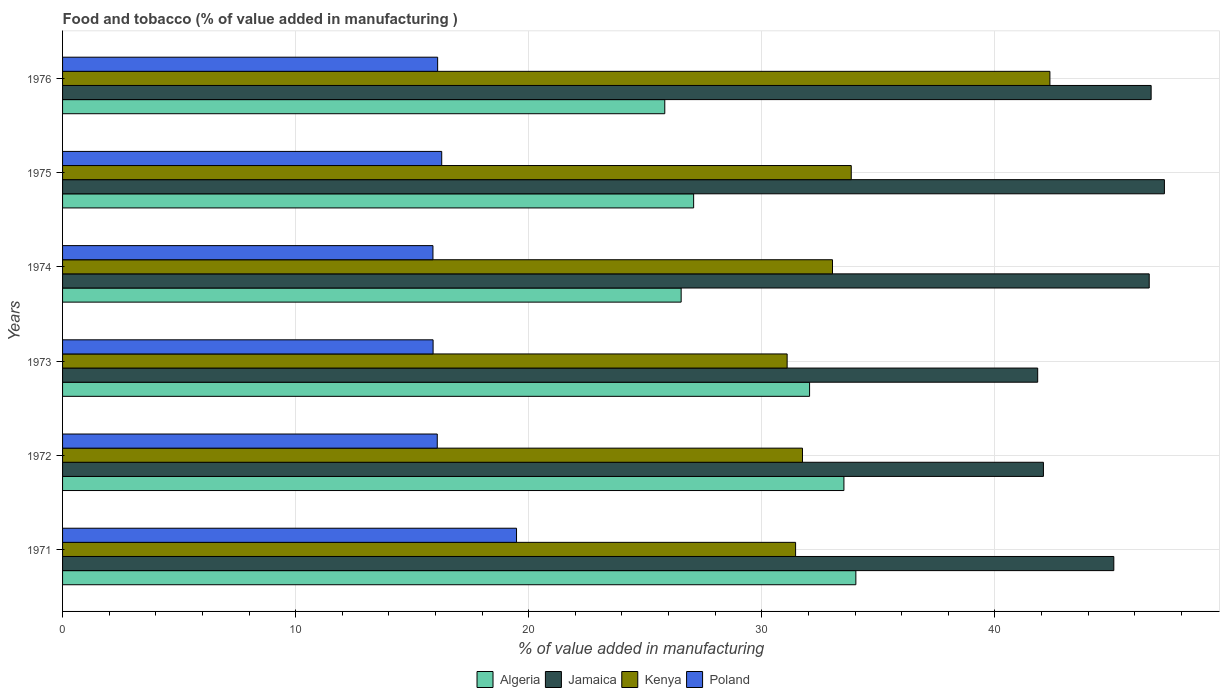How many different coloured bars are there?
Provide a short and direct response. 4. What is the label of the 1st group of bars from the top?
Make the answer very short. 1976. In how many cases, is the number of bars for a given year not equal to the number of legend labels?
Provide a succinct answer. 0. What is the value added in manufacturing food and tobacco in Algeria in 1976?
Your answer should be very brief. 25.84. Across all years, what is the maximum value added in manufacturing food and tobacco in Poland?
Provide a succinct answer. 19.48. Across all years, what is the minimum value added in manufacturing food and tobacco in Jamaica?
Your response must be concise. 41.84. In which year was the value added in manufacturing food and tobacco in Kenya maximum?
Your answer should be compact. 1976. In which year was the value added in manufacturing food and tobacco in Poland minimum?
Provide a succinct answer. 1974. What is the total value added in manufacturing food and tobacco in Algeria in the graph?
Ensure brevity in your answer.  179.06. What is the difference between the value added in manufacturing food and tobacco in Algeria in 1973 and that in 1974?
Offer a very short reply. 5.51. What is the difference between the value added in manufacturing food and tobacco in Jamaica in 1973 and the value added in manufacturing food and tobacco in Algeria in 1974?
Your response must be concise. 15.3. What is the average value added in manufacturing food and tobacco in Kenya per year?
Offer a very short reply. 33.92. In the year 1971, what is the difference between the value added in manufacturing food and tobacco in Poland and value added in manufacturing food and tobacco in Kenya?
Provide a short and direct response. -11.97. What is the ratio of the value added in manufacturing food and tobacco in Jamaica in 1971 to that in 1974?
Ensure brevity in your answer.  0.97. Is the difference between the value added in manufacturing food and tobacco in Poland in 1974 and 1975 greater than the difference between the value added in manufacturing food and tobacco in Kenya in 1974 and 1975?
Your response must be concise. Yes. What is the difference between the highest and the second highest value added in manufacturing food and tobacco in Algeria?
Make the answer very short. 0.51. What is the difference between the highest and the lowest value added in manufacturing food and tobacco in Poland?
Provide a short and direct response. 3.59. Is the sum of the value added in manufacturing food and tobacco in Algeria in 1975 and 1976 greater than the maximum value added in manufacturing food and tobacco in Jamaica across all years?
Offer a terse response. Yes. Is it the case that in every year, the sum of the value added in manufacturing food and tobacco in Poland and value added in manufacturing food and tobacco in Jamaica is greater than the sum of value added in manufacturing food and tobacco in Algeria and value added in manufacturing food and tobacco in Kenya?
Offer a terse response. No. What does the 4th bar from the top in 1976 represents?
Your answer should be compact. Algeria. What does the 3rd bar from the bottom in 1972 represents?
Ensure brevity in your answer.  Kenya. How many years are there in the graph?
Your response must be concise. 6. What is the difference between two consecutive major ticks on the X-axis?
Offer a very short reply. 10. How many legend labels are there?
Keep it short and to the point. 4. How are the legend labels stacked?
Provide a succinct answer. Horizontal. What is the title of the graph?
Offer a very short reply. Food and tobacco (% of value added in manufacturing ). What is the label or title of the X-axis?
Provide a succinct answer. % of value added in manufacturing. What is the label or title of the Y-axis?
Give a very brief answer. Years. What is the % of value added in manufacturing of Algeria in 1971?
Provide a short and direct response. 34.04. What is the % of value added in manufacturing in Jamaica in 1971?
Give a very brief answer. 45.1. What is the % of value added in manufacturing of Kenya in 1971?
Keep it short and to the point. 31.45. What is the % of value added in manufacturing in Poland in 1971?
Give a very brief answer. 19.48. What is the % of value added in manufacturing of Algeria in 1972?
Offer a very short reply. 33.52. What is the % of value added in manufacturing in Jamaica in 1972?
Your answer should be compact. 42.08. What is the % of value added in manufacturing of Kenya in 1972?
Provide a succinct answer. 31.75. What is the % of value added in manufacturing in Poland in 1972?
Provide a short and direct response. 16.08. What is the % of value added in manufacturing in Algeria in 1973?
Provide a succinct answer. 32.05. What is the % of value added in manufacturing in Jamaica in 1973?
Provide a succinct answer. 41.84. What is the % of value added in manufacturing of Kenya in 1973?
Make the answer very short. 31.09. What is the % of value added in manufacturing in Poland in 1973?
Ensure brevity in your answer.  15.9. What is the % of value added in manufacturing in Algeria in 1974?
Your answer should be very brief. 26.54. What is the % of value added in manufacturing of Jamaica in 1974?
Ensure brevity in your answer.  46.62. What is the % of value added in manufacturing in Kenya in 1974?
Provide a short and direct response. 33.03. What is the % of value added in manufacturing in Poland in 1974?
Provide a succinct answer. 15.89. What is the % of value added in manufacturing of Algeria in 1975?
Your response must be concise. 27.08. What is the % of value added in manufacturing of Jamaica in 1975?
Offer a terse response. 47.27. What is the % of value added in manufacturing of Kenya in 1975?
Ensure brevity in your answer.  33.84. What is the % of value added in manufacturing in Poland in 1975?
Keep it short and to the point. 16.27. What is the % of value added in manufacturing of Algeria in 1976?
Make the answer very short. 25.84. What is the % of value added in manufacturing of Jamaica in 1976?
Make the answer very short. 46.7. What is the % of value added in manufacturing of Kenya in 1976?
Your answer should be very brief. 42.36. What is the % of value added in manufacturing of Poland in 1976?
Your response must be concise. 16.09. Across all years, what is the maximum % of value added in manufacturing in Algeria?
Give a very brief answer. 34.04. Across all years, what is the maximum % of value added in manufacturing of Jamaica?
Give a very brief answer. 47.27. Across all years, what is the maximum % of value added in manufacturing of Kenya?
Keep it short and to the point. 42.36. Across all years, what is the maximum % of value added in manufacturing in Poland?
Provide a succinct answer. 19.48. Across all years, what is the minimum % of value added in manufacturing in Algeria?
Offer a terse response. 25.84. Across all years, what is the minimum % of value added in manufacturing in Jamaica?
Provide a short and direct response. 41.84. Across all years, what is the minimum % of value added in manufacturing in Kenya?
Provide a short and direct response. 31.09. Across all years, what is the minimum % of value added in manufacturing in Poland?
Provide a short and direct response. 15.89. What is the total % of value added in manufacturing in Algeria in the graph?
Ensure brevity in your answer.  179.06. What is the total % of value added in manufacturing of Jamaica in the graph?
Your answer should be compact. 269.62. What is the total % of value added in manufacturing of Kenya in the graph?
Offer a very short reply. 203.51. What is the total % of value added in manufacturing in Poland in the graph?
Ensure brevity in your answer.  99.7. What is the difference between the % of value added in manufacturing of Algeria in 1971 and that in 1972?
Your answer should be compact. 0.51. What is the difference between the % of value added in manufacturing in Jamaica in 1971 and that in 1972?
Offer a very short reply. 3.02. What is the difference between the % of value added in manufacturing of Kenya in 1971 and that in 1972?
Keep it short and to the point. -0.3. What is the difference between the % of value added in manufacturing of Poland in 1971 and that in 1972?
Your answer should be very brief. 3.4. What is the difference between the % of value added in manufacturing in Algeria in 1971 and that in 1973?
Your answer should be compact. 1.99. What is the difference between the % of value added in manufacturing in Jamaica in 1971 and that in 1973?
Your answer should be very brief. 3.27. What is the difference between the % of value added in manufacturing of Kenya in 1971 and that in 1973?
Make the answer very short. 0.36. What is the difference between the % of value added in manufacturing of Poland in 1971 and that in 1973?
Your answer should be compact. 3.58. What is the difference between the % of value added in manufacturing of Algeria in 1971 and that in 1974?
Make the answer very short. 7.5. What is the difference between the % of value added in manufacturing in Jamaica in 1971 and that in 1974?
Offer a very short reply. -1.52. What is the difference between the % of value added in manufacturing in Kenya in 1971 and that in 1974?
Your answer should be very brief. -1.58. What is the difference between the % of value added in manufacturing in Poland in 1971 and that in 1974?
Provide a short and direct response. 3.59. What is the difference between the % of value added in manufacturing in Algeria in 1971 and that in 1975?
Ensure brevity in your answer.  6.96. What is the difference between the % of value added in manufacturing in Jamaica in 1971 and that in 1975?
Give a very brief answer. -2.17. What is the difference between the % of value added in manufacturing of Kenya in 1971 and that in 1975?
Provide a short and direct response. -2.39. What is the difference between the % of value added in manufacturing in Poland in 1971 and that in 1975?
Keep it short and to the point. 3.21. What is the difference between the % of value added in manufacturing in Algeria in 1971 and that in 1976?
Your response must be concise. 8.2. What is the difference between the % of value added in manufacturing in Jamaica in 1971 and that in 1976?
Your response must be concise. -1.6. What is the difference between the % of value added in manufacturing in Kenya in 1971 and that in 1976?
Offer a very short reply. -10.91. What is the difference between the % of value added in manufacturing of Poland in 1971 and that in 1976?
Make the answer very short. 3.38. What is the difference between the % of value added in manufacturing of Algeria in 1972 and that in 1973?
Your answer should be compact. 1.47. What is the difference between the % of value added in manufacturing of Jamaica in 1972 and that in 1973?
Provide a succinct answer. 0.25. What is the difference between the % of value added in manufacturing in Kenya in 1972 and that in 1973?
Your answer should be compact. 0.66. What is the difference between the % of value added in manufacturing in Poland in 1972 and that in 1973?
Your answer should be very brief. 0.18. What is the difference between the % of value added in manufacturing of Algeria in 1972 and that in 1974?
Your answer should be compact. 6.98. What is the difference between the % of value added in manufacturing of Jamaica in 1972 and that in 1974?
Ensure brevity in your answer.  -4.54. What is the difference between the % of value added in manufacturing in Kenya in 1972 and that in 1974?
Your answer should be very brief. -1.29. What is the difference between the % of value added in manufacturing in Poland in 1972 and that in 1974?
Give a very brief answer. 0.19. What is the difference between the % of value added in manufacturing of Algeria in 1972 and that in 1975?
Offer a terse response. 6.45. What is the difference between the % of value added in manufacturing in Jamaica in 1972 and that in 1975?
Your answer should be compact. -5.19. What is the difference between the % of value added in manufacturing of Kenya in 1972 and that in 1975?
Provide a succinct answer. -2.09. What is the difference between the % of value added in manufacturing in Poland in 1972 and that in 1975?
Ensure brevity in your answer.  -0.19. What is the difference between the % of value added in manufacturing of Algeria in 1972 and that in 1976?
Provide a succinct answer. 7.69. What is the difference between the % of value added in manufacturing in Jamaica in 1972 and that in 1976?
Your answer should be very brief. -4.62. What is the difference between the % of value added in manufacturing of Kenya in 1972 and that in 1976?
Provide a succinct answer. -10.61. What is the difference between the % of value added in manufacturing of Poland in 1972 and that in 1976?
Offer a very short reply. -0.02. What is the difference between the % of value added in manufacturing of Algeria in 1973 and that in 1974?
Make the answer very short. 5.51. What is the difference between the % of value added in manufacturing of Jamaica in 1973 and that in 1974?
Your answer should be very brief. -4.78. What is the difference between the % of value added in manufacturing of Kenya in 1973 and that in 1974?
Provide a short and direct response. -1.95. What is the difference between the % of value added in manufacturing of Poland in 1973 and that in 1974?
Provide a succinct answer. 0.01. What is the difference between the % of value added in manufacturing in Algeria in 1973 and that in 1975?
Offer a very short reply. 4.97. What is the difference between the % of value added in manufacturing in Jamaica in 1973 and that in 1975?
Give a very brief answer. -5.44. What is the difference between the % of value added in manufacturing in Kenya in 1973 and that in 1975?
Offer a very short reply. -2.75. What is the difference between the % of value added in manufacturing of Poland in 1973 and that in 1975?
Your answer should be compact. -0.37. What is the difference between the % of value added in manufacturing of Algeria in 1973 and that in 1976?
Your answer should be compact. 6.21. What is the difference between the % of value added in manufacturing in Jamaica in 1973 and that in 1976?
Make the answer very short. -4.87. What is the difference between the % of value added in manufacturing of Kenya in 1973 and that in 1976?
Ensure brevity in your answer.  -11.27. What is the difference between the % of value added in manufacturing in Poland in 1973 and that in 1976?
Your response must be concise. -0.2. What is the difference between the % of value added in manufacturing in Algeria in 1974 and that in 1975?
Your answer should be compact. -0.54. What is the difference between the % of value added in manufacturing of Jamaica in 1974 and that in 1975?
Offer a terse response. -0.65. What is the difference between the % of value added in manufacturing of Kenya in 1974 and that in 1975?
Make the answer very short. -0.8. What is the difference between the % of value added in manufacturing of Poland in 1974 and that in 1975?
Give a very brief answer. -0.38. What is the difference between the % of value added in manufacturing in Algeria in 1974 and that in 1976?
Provide a succinct answer. 0.7. What is the difference between the % of value added in manufacturing in Jamaica in 1974 and that in 1976?
Provide a short and direct response. -0.08. What is the difference between the % of value added in manufacturing of Kenya in 1974 and that in 1976?
Make the answer very short. -9.33. What is the difference between the % of value added in manufacturing in Poland in 1974 and that in 1976?
Your answer should be very brief. -0.2. What is the difference between the % of value added in manufacturing of Algeria in 1975 and that in 1976?
Provide a short and direct response. 1.24. What is the difference between the % of value added in manufacturing of Jamaica in 1975 and that in 1976?
Provide a short and direct response. 0.57. What is the difference between the % of value added in manufacturing of Kenya in 1975 and that in 1976?
Your answer should be very brief. -8.52. What is the difference between the % of value added in manufacturing of Poland in 1975 and that in 1976?
Provide a succinct answer. 0.17. What is the difference between the % of value added in manufacturing of Algeria in 1971 and the % of value added in manufacturing of Jamaica in 1972?
Your answer should be compact. -8.05. What is the difference between the % of value added in manufacturing of Algeria in 1971 and the % of value added in manufacturing of Kenya in 1972?
Keep it short and to the point. 2.29. What is the difference between the % of value added in manufacturing in Algeria in 1971 and the % of value added in manufacturing in Poland in 1972?
Offer a terse response. 17.96. What is the difference between the % of value added in manufacturing in Jamaica in 1971 and the % of value added in manufacturing in Kenya in 1972?
Offer a very short reply. 13.36. What is the difference between the % of value added in manufacturing in Jamaica in 1971 and the % of value added in manufacturing in Poland in 1972?
Offer a terse response. 29.03. What is the difference between the % of value added in manufacturing in Kenya in 1971 and the % of value added in manufacturing in Poland in 1972?
Your response must be concise. 15.37. What is the difference between the % of value added in manufacturing in Algeria in 1971 and the % of value added in manufacturing in Jamaica in 1973?
Ensure brevity in your answer.  -7.8. What is the difference between the % of value added in manufacturing of Algeria in 1971 and the % of value added in manufacturing of Kenya in 1973?
Offer a very short reply. 2.95. What is the difference between the % of value added in manufacturing in Algeria in 1971 and the % of value added in manufacturing in Poland in 1973?
Your answer should be compact. 18.14. What is the difference between the % of value added in manufacturing in Jamaica in 1971 and the % of value added in manufacturing in Kenya in 1973?
Provide a short and direct response. 14.02. What is the difference between the % of value added in manufacturing of Jamaica in 1971 and the % of value added in manufacturing of Poland in 1973?
Provide a short and direct response. 29.21. What is the difference between the % of value added in manufacturing of Kenya in 1971 and the % of value added in manufacturing of Poland in 1973?
Offer a very short reply. 15.55. What is the difference between the % of value added in manufacturing of Algeria in 1971 and the % of value added in manufacturing of Jamaica in 1974?
Give a very brief answer. -12.59. What is the difference between the % of value added in manufacturing of Algeria in 1971 and the % of value added in manufacturing of Poland in 1974?
Ensure brevity in your answer.  18.14. What is the difference between the % of value added in manufacturing in Jamaica in 1971 and the % of value added in manufacturing in Kenya in 1974?
Offer a terse response. 12.07. What is the difference between the % of value added in manufacturing in Jamaica in 1971 and the % of value added in manufacturing in Poland in 1974?
Keep it short and to the point. 29.21. What is the difference between the % of value added in manufacturing in Kenya in 1971 and the % of value added in manufacturing in Poland in 1974?
Your answer should be compact. 15.56. What is the difference between the % of value added in manufacturing in Algeria in 1971 and the % of value added in manufacturing in Jamaica in 1975?
Your answer should be very brief. -13.24. What is the difference between the % of value added in manufacturing in Algeria in 1971 and the % of value added in manufacturing in Kenya in 1975?
Make the answer very short. 0.2. What is the difference between the % of value added in manufacturing of Algeria in 1971 and the % of value added in manufacturing of Poland in 1975?
Ensure brevity in your answer.  17.77. What is the difference between the % of value added in manufacturing in Jamaica in 1971 and the % of value added in manufacturing in Kenya in 1975?
Offer a terse response. 11.27. What is the difference between the % of value added in manufacturing in Jamaica in 1971 and the % of value added in manufacturing in Poland in 1975?
Keep it short and to the point. 28.84. What is the difference between the % of value added in manufacturing of Kenya in 1971 and the % of value added in manufacturing of Poland in 1975?
Your answer should be compact. 15.18. What is the difference between the % of value added in manufacturing of Algeria in 1971 and the % of value added in manufacturing of Jamaica in 1976?
Your response must be concise. -12.67. What is the difference between the % of value added in manufacturing of Algeria in 1971 and the % of value added in manufacturing of Kenya in 1976?
Your response must be concise. -8.32. What is the difference between the % of value added in manufacturing of Algeria in 1971 and the % of value added in manufacturing of Poland in 1976?
Offer a terse response. 17.94. What is the difference between the % of value added in manufacturing of Jamaica in 1971 and the % of value added in manufacturing of Kenya in 1976?
Keep it short and to the point. 2.74. What is the difference between the % of value added in manufacturing of Jamaica in 1971 and the % of value added in manufacturing of Poland in 1976?
Ensure brevity in your answer.  29.01. What is the difference between the % of value added in manufacturing of Kenya in 1971 and the % of value added in manufacturing of Poland in 1976?
Ensure brevity in your answer.  15.36. What is the difference between the % of value added in manufacturing in Algeria in 1972 and the % of value added in manufacturing in Jamaica in 1973?
Give a very brief answer. -8.31. What is the difference between the % of value added in manufacturing in Algeria in 1972 and the % of value added in manufacturing in Kenya in 1973?
Provide a short and direct response. 2.44. What is the difference between the % of value added in manufacturing of Algeria in 1972 and the % of value added in manufacturing of Poland in 1973?
Keep it short and to the point. 17.63. What is the difference between the % of value added in manufacturing of Jamaica in 1972 and the % of value added in manufacturing of Kenya in 1973?
Your answer should be very brief. 11. What is the difference between the % of value added in manufacturing of Jamaica in 1972 and the % of value added in manufacturing of Poland in 1973?
Your answer should be very brief. 26.19. What is the difference between the % of value added in manufacturing in Kenya in 1972 and the % of value added in manufacturing in Poland in 1973?
Offer a terse response. 15.85. What is the difference between the % of value added in manufacturing of Algeria in 1972 and the % of value added in manufacturing of Jamaica in 1974?
Ensure brevity in your answer.  -13.1. What is the difference between the % of value added in manufacturing of Algeria in 1972 and the % of value added in manufacturing of Kenya in 1974?
Give a very brief answer. 0.49. What is the difference between the % of value added in manufacturing in Algeria in 1972 and the % of value added in manufacturing in Poland in 1974?
Your response must be concise. 17.63. What is the difference between the % of value added in manufacturing in Jamaica in 1972 and the % of value added in manufacturing in Kenya in 1974?
Your response must be concise. 9.05. What is the difference between the % of value added in manufacturing of Jamaica in 1972 and the % of value added in manufacturing of Poland in 1974?
Ensure brevity in your answer.  26.19. What is the difference between the % of value added in manufacturing in Kenya in 1972 and the % of value added in manufacturing in Poland in 1974?
Your answer should be very brief. 15.85. What is the difference between the % of value added in manufacturing in Algeria in 1972 and the % of value added in manufacturing in Jamaica in 1975?
Make the answer very short. -13.75. What is the difference between the % of value added in manufacturing in Algeria in 1972 and the % of value added in manufacturing in Kenya in 1975?
Ensure brevity in your answer.  -0.31. What is the difference between the % of value added in manufacturing in Algeria in 1972 and the % of value added in manufacturing in Poland in 1975?
Provide a short and direct response. 17.26. What is the difference between the % of value added in manufacturing of Jamaica in 1972 and the % of value added in manufacturing of Kenya in 1975?
Your response must be concise. 8.25. What is the difference between the % of value added in manufacturing of Jamaica in 1972 and the % of value added in manufacturing of Poland in 1975?
Your answer should be very brief. 25.81. What is the difference between the % of value added in manufacturing of Kenya in 1972 and the % of value added in manufacturing of Poland in 1975?
Your answer should be very brief. 15.48. What is the difference between the % of value added in manufacturing of Algeria in 1972 and the % of value added in manufacturing of Jamaica in 1976?
Provide a succinct answer. -13.18. What is the difference between the % of value added in manufacturing in Algeria in 1972 and the % of value added in manufacturing in Kenya in 1976?
Your answer should be very brief. -8.84. What is the difference between the % of value added in manufacturing in Algeria in 1972 and the % of value added in manufacturing in Poland in 1976?
Offer a terse response. 17.43. What is the difference between the % of value added in manufacturing of Jamaica in 1972 and the % of value added in manufacturing of Kenya in 1976?
Keep it short and to the point. -0.28. What is the difference between the % of value added in manufacturing of Jamaica in 1972 and the % of value added in manufacturing of Poland in 1976?
Make the answer very short. 25.99. What is the difference between the % of value added in manufacturing in Kenya in 1972 and the % of value added in manufacturing in Poland in 1976?
Ensure brevity in your answer.  15.65. What is the difference between the % of value added in manufacturing of Algeria in 1973 and the % of value added in manufacturing of Jamaica in 1974?
Give a very brief answer. -14.57. What is the difference between the % of value added in manufacturing of Algeria in 1973 and the % of value added in manufacturing of Kenya in 1974?
Provide a succinct answer. -0.98. What is the difference between the % of value added in manufacturing in Algeria in 1973 and the % of value added in manufacturing in Poland in 1974?
Ensure brevity in your answer.  16.16. What is the difference between the % of value added in manufacturing of Jamaica in 1973 and the % of value added in manufacturing of Kenya in 1974?
Keep it short and to the point. 8.8. What is the difference between the % of value added in manufacturing in Jamaica in 1973 and the % of value added in manufacturing in Poland in 1974?
Offer a terse response. 25.95. What is the difference between the % of value added in manufacturing in Kenya in 1973 and the % of value added in manufacturing in Poland in 1974?
Give a very brief answer. 15.2. What is the difference between the % of value added in manufacturing of Algeria in 1973 and the % of value added in manufacturing of Jamaica in 1975?
Offer a very short reply. -15.22. What is the difference between the % of value added in manufacturing in Algeria in 1973 and the % of value added in manufacturing in Kenya in 1975?
Your response must be concise. -1.79. What is the difference between the % of value added in manufacturing of Algeria in 1973 and the % of value added in manufacturing of Poland in 1975?
Your answer should be very brief. 15.78. What is the difference between the % of value added in manufacturing in Jamaica in 1973 and the % of value added in manufacturing in Kenya in 1975?
Make the answer very short. 8. What is the difference between the % of value added in manufacturing in Jamaica in 1973 and the % of value added in manufacturing in Poland in 1975?
Offer a very short reply. 25.57. What is the difference between the % of value added in manufacturing of Kenya in 1973 and the % of value added in manufacturing of Poland in 1975?
Make the answer very short. 14.82. What is the difference between the % of value added in manufacturing in Algeria in 1973 and the % of value added in manufacturing in Jamaica in 1976?
Give a very brief answer. -14.65. What is the difference between the % of value added in manufacturing in Algeria in 1973 and the % of value added in manufacturing in Kenya in 1976?
Your answer should be very brief. -10.31. What is the difference between the % of value added in manufacturing in Algeria in 1973 and the % of value added in manufacturing in Poland in 1976?
Offer a terse response. 15.96. What is the difference between the % of value added in manufacturing of Jamaica in 1973 and the % of value added in manufacturing of Kenya in 1976?
Provide a succinct answer. -0.52. What is the difference between the % of value added in manufacturing in Jamaica in 1973 and the % of value added in manufacturing in Poland in 1976?
Keep it short and to the point. 25.74. What is the difference between the % of value added in manufacturing of Kenya in 1973 and the % of value added in manufacturing of Poland in 1976?
Offer a very short reply. 14.99. What is the difference between the % of value added in manufacturing of Algeria in 1974 and the % of value added in manufacturing of Jamaica in 1975?
Your response must be concise. -20.73. What is the difference between the % of value added in manufacturing of Algeria in 1974 and the % of value added in manufacturing of Kenya in 1975?
Ensure brevity in your answer.  -7.3. What is the difference between the % of value added in manufacturing in Algeria in 1974 and the % of value added in manufacturing in Poland in 1975?
Provide a short and direct response. 10.27. What is the difference between the % of value added in manufacturing in Jamaica in 1974 and the % of value added in manufacturing in Kenya in 1975?
Provide a succinct answer. 12.78. What is the difference between the % of value added in manufacturing of Jamaica in 1974 and the % of value added in manufacturing of Poland in 1975?
Give a very brief answer. 30.35. What is the difference between the % of value added in manufacturing in Kenya in 1974 and the % of value added in manufacturing in Poland in 1975?
Provide a succinct answer. 16.77. What is the difference between the % of value added in manufacturing of Algeria in 1974 and the % of value added in manufacturing of Jamaica in 1976?
Offer a very short reply. -20.16. What is the difference between the % of value added in manufacturing of Algeria in 1974 and the % of value added in manufacturing of Kenya in 1976?
Provide a succinct answer. -15.82. What is the difference between the % of value added in manufacturing in Algeria in 1974 and the % of value added in manufacturing in Poland in 1976?
Ensure brevity in your answer.  10.45. What is the difference between the % of value added in manufacturing in Jamaica in 1974 and the % of value added in manufacturing in Kenya in 1976?
Ensure brevity in your answer.  4.26. What is the difference between the % of value added in manufacturing in Jamaica in 1974 and the % of value added in manufacturing in Poland in 1976?
Offer a terse response. 30.53. What is the difference between the % of value added in manufacturing of Kenya in 1974 and the % of value added in manufacturing of Poland in 1976?
Provide a succinct answer. 16.94. What is the difference between the % of value added in manufacturing in Algeria in 1975 and the % of value added in manufacturing in Jamaica in 1976?
Your response must be concise. -19.63. What is the difference between the % of value added in manufacturing of Algeria in 1975 and the % of value added in manufacturing of Kenya in 1976?
Your answer should be compact. -15.28. What is the difference between the % of value added in manufacturing of Algeria in 1975 and the % of value added in manufacturing of Poland in 1976?
Your answer should be very brief. 10.98. What is the difference between the % of value added in manufacturing in Jamaica in 1975 and the % of value added in manufacturing in Kenya in 1976?
Offer a very short reply. 4.91. What is the difference between the % of value added in manufacturing of Jamaica in 1975 and the % of value added in manufacturing of Poland in 1976?
Ensure brevity in your answer.  31.18. What is the difference between the % of value added in manufacturing in Kenya in 1975 and the % of value added in manufacturing in Poland in 1976?
Provide a short and direct response. 17.74. What is the average % of value added in manufacturing in Algeria per year?
Offer a very short reply. 29.84. What is the average % of value added in manufacturing in Jamaica per year?
Ensure brevity in your answer.  44.94. What is the average % of value added in manufacturing of Kenya per year?
Ensure brevity in your answer.  33.92. What is the average % of value added in manufacturing of Poland per year?
Give a very brief answer. 16.62. In the year 1971, what is the difference between the % of value added in manufacturing of Algeria and % of value added in manufacturing of Jamaica?
Provide a succinct answer. -11.07. In the year 1971, what is the difference between the % of value added in manufacturing in Algeria and % of value added in manufacturing in Kenya?
Offer a very short reply. 2.59. In the year 1971, what is the difference between the % of value added in manufacturing of Algeria and % of value added in manufacturing of Poland?
Provide a short and direct response. 14.56. In the year 1971, what is the difference between the % of value added in manufacturing of Jamaica and % of value added in manufacturing of Kenya?
Provide a succinct answer. 13.65. In the year 1971, what is the difference between the % of value added in manufacturing in Jamaica and % of value added in manufacturing in Poland?
Offer a very short reply. 25.63. In the year 1971, what is the difference between the % of value added in manufacturing in Kenya and % of value added in manufacturing in Poland?
Your answer should be very brief. 11.97. In the year 1972, what is the difference between the % of value added in manufacturing in Algeria and % of value added in manufacturing in Jamaica?
Your answer should be very brief. -8.56. In the year 1972, what is the difference between the % of value added in manufacturing of Algeria and % of value added in manufacturing of Kenya?
Offer a very short reply. 1.78. In the year 1972, what is the difference between the % of value added in manufacturing in Algeria and % of value added in manufacturing in Poland?
Keep it short and to the point. 17.45. In the year 1972, what is the difference between the % of value added in manufacturing of Jamaica and % of value added in manufacturing of Kenya?
Offer a very short reply. 10.34. In the year 1972, what is the difference between the % of value added in manufacturing of Jamaica and % of value added in manufacturing of Poland?
Offer a terse response. 26.01. In the year 1972, what is the difference between the % of value added in manufacturing of Kenya and % of value added in manufacturing of Poland?
Your answer should be very brief. 15.67. In the year 1973, what is the difference between the % of value added in manufacturing of Algeria and % of value added in manufacturing of Jamaica?
Ensure brevity in your answer.  -9.79. In the year 1973, what is the difference between the % of value added in manufacturing of Algeria and % of value added in manufacturing of Poland?
Your answer should be compact. 16.15. In the year 1973, what is the difference between the % of value added in manufacturing of Jamaica and % of value added in manufacturing of Kenya?
Your response must be concise. 10.75. In the year 1973, what is the difference between the % of value added in manufacturing in Jamaica and % of value added in manufacturing in Poland?
Give a very brief answer. 25.94. In the year 1973, what is the difference between the % of value added in manufacturing of Kenya and % of value added in manufacturing of Poland?
Your response must be concise. 15.19. In the year 1974, what is the difference between the % of value added in manufacturing in Algeria and % of value added in manufacturing in Jamaica?
Offer a very short reply. -20.08. In the year 1974, what is the difference between the % of value added in manufacturing in Algeria and % of value added in manufacturing in Kenya?
Give a very brief answer. -6.49. In the year 1974, what is the difference between the % of value added in manufacturing of Algeria and % of value added in manufacturing of Poland?
Offer a terse response. 10.65. In the year 1974, what is the difference between the % of value added in manufacturing in Jamaica and % of value added in manufacturing in Kenya?
Ensure brevity in your answer.  13.59. In the year 1974, what is the difference between the % of value added in manufacturing in Jamaica and % of value added in manufacturing in Poland?
Offer a terse response. 30.73. In the year 1974, what is the difference between the % of value added in manufacturing in Kenya and % of value added in manufacturing in Poland?
Give a very brief answer. 17.14. In the year 1975, what is the difference between the % of value added in manufacturing of Algeria and % of value added in manufacturing of Jamaica?
Provide a short and direct response. -20.2. In the year 1975, what is the difference between the % of value added in manufacturing of Algeria and % of value added in manufacturing of Kenya?
Ensure brevity in your answer.  -6.76. In the year 1975, what is the difference between the % of value added in manufacturing of Algeria and % of value added in manufacturing of Poland?
Give a very brief answer. 10.81. In the year 1975, what is the difference between the % of value added in manufacturing in Jamaica and % of value added in manufacturing in Kenya?
Your answer should be compact. 13.44. In the year 1975, what is the difference between the % of value added in manufacturing in Jamaica and % of value added in manufacturing in Poland?
Offer a very short reply. 31.01. In the year 1975, what is the difference between the % of value added in manufacturing in Kenya and % of value added in manufacturing in Poland?
Your answer should be very brief. 17.57. In the year 1976, what is the difference between the % of value added in manufacturing of Algeria and % of value added in manufacturing of Jamaica?
Offer a terse response. -20.87. In the year 1976, what is the difference between the % of value added in manufacturing in Algeria and % of value added in manufacturing in Kenya?
Your response must be concise. -16.52. In the year 1976, what is the difference between the % of value added in manufacturing in Algeria and % of value added in manufacturing in Poland?
Offer a very short reply. 9.74. In the year 1976, what is the difference between the % of value added in manufacturing in Jamaica and % of value added in manufacturing in Kenya?
Offer a terse response. 4.34. In the year 1976, what is the difference between the % of value added in manufacturing of Jamaica and % of value added in manufacturing of Poland?
Your answer should be compact. 30.61. In the year 1976, what is the difference between the % of value added in manufacturing of Kenya and % of value added in manufacturing of Poland?
Offer a terse response. 26.27. What is the ratio of the % of value added in manufacturing in Algeria in 1971 to that in 1972?
Make the answer very short. 1.02. What is the ratio of the % of value added in manufacturing of Jamaica in 1971 to that in 1972?
Provide a short and direct response. 1.07. What is the ratio of the % of value added in manufacturing of Poland in 1971 to that in 1972?
Provide a short and direct response. 1.21. What is the ratio of the % of value added in manufacturing in Algeria in 1971 to that in 1973?
Provide a succinct answer. 1.06. What is the ratio of the % of value added in manufacturing in Jamaica in 1971 to that in 1973?
Your answer should be very brief. 1.08. What is the ratio of the % of value added in manufacturing of Kenya in 1971 to that in 1973?
Keep it short and to the point. 1.01. What is the ratio of the % of value added in manufacturing in Poland in 1971 to that in 1973?
Offer a terse response. 1.23. What is the ratio of the % of value added in manufacturing in Algeria in 1971 to that in 1974?
Provide a short and direct response. 1.28. What is the ratio of the % of value added in manufacturing in Jamaica in 1971 to that in 1974?
Your answer should be compact. 0.97. What is the ratio of the % of value added in manufacturing in Kenya in 1971 to that in 1974?
Make the answer very short. 0.95. What is the ratio of the % of value added in manufacturing of Poland in 1971 to that in 1974?
Provide a short and direct response. 1.23. What is the ratio of the % of value added in manufacturing of Algeria in 1971 to that in 1975?
Offer a terse response. 1.26. What is the ratio of the % of value added in manufacturing in Jamaica in 1971 to that in 1975?
Your response must be concise. 0.95. What is the ratio of the % of value added in manufacturing in Kenya in 1971 to that in 1975?
Keep it short and to the point. 0.93. What is the ratio of the % of value added in manufacturing in Poland in 1971 to that in 1975?
Ensure brevity in your answer.  1.2. What is the ratio of the % of value added in manufacturing in Algeria in 1971 to that in 1976?
Your response must be concise. 1.32. What is the ratio of the % of value added in manufacturing of Jamaica in 1971 to that in 1976?
Ensure brevity in your answer.  0.97. What is the ratio of the % of value added in manufacturing of Kenya in 1971 to that in 1976?
Keep it short and to the point. 0.74. What is the ratio of the % of value added in manufacturing in Poland in 1971 to that in 1976?
Offer a very short reply. 1.21. What is the ratio of the % of value added in manufacturing of Algeria in 1972 to that in 1973?
Offer a very short reply. 1.05. What is the ratio of the % of value added in manufacturing in Jamaica in 1972 to that in 1973?
Give a very brief answer. 1.01. What is the ratio of the % of value added in manufacturing in Kenya in 1972 to that in 1973?
Your answer should be compact. 1.02. What is the ratio of the % of value added in manufacturing in Poland in 1972 to that in 1973?
Keep it short and to the point. 1.01. What is the ratio of the % of value added in manufacturing in Algeria in 1972 to that in 1974?
Your answer should be compact. 1.26. What is the ratio of the % of value added in manufacturing of Jamaica in 1972 to that in 1974?
Ensure brevity in your answer.  0.9. What is the ratio of the % of value added in manufacturing in Kenya in 1972 to that in 1974?
Offer a very short reply. 0.96. What is the ratio of the % of value added in manufacturing of Poland in 1972 to that in 1974?
Provide a short and direct response. 1.01. What is the ratio of the % of value added in manufacturing in Algeria in 1972 to that in 1975?
Keep it short and to the point. 1.24. What is the ratio of the % of value added in manufacturing in Jamaica in 1972 to that in 1975?
Provide a succinct answer. 0.89. What is the ratio of the % of value added in manufacturing in Kenya in 1972 to that in 1975?
Your response must be concise. 0.94. What is the ratio of the % of value added in manufacturing in Algeria in 1972 to that in 1976?
Ensure brevity in your answer.  1.3. What is the ratio of the % of value added in manufacturing of Jamaica in 1972 to that in 1976?
Your answer should be compact. 0.9. What is the ratio of the % of value added in manufacturing in Kenya in 1972 to that in 1976?
Your answer should be very brief. 0.75. What is the ratio of the % of value added in manufacturing of Poland in 1972 to that in 1976?
Provide a succinct answer. 1. What is the ratio of the % of value added in manufacturing of Algeria in 1973 to that in 1974?
Ensure brevity in your answer.  1.21. What is the ratio of the % of value added in manufacturing of Jamaica in 1973 to that in 1974?
Keep it short and to the point. 0.9. What is the ratio of the % of value added in manufacturing of Kenya in 1973 to that in 1974?
Provide a succinct answer. 0.94. What is the ratio of the % of value added in manufacturing in Algeria in 1973 to that in 1975?
Provide a short and direct response. 1.18. What is the ratio of the % of value added in manufacturing of Jamaica in 1973 to that in 1975?
Offer a terse response. 0.89. What is the ratio of the % of value added in manufacturing of Kenya in 1973 to that in 1975?
Your answer should be compact. 0.92. What is the ratio of the % of value added in manufacturing of Poland in 1973 to that in 1975?
Give a very brief answer. 0.98. What is the ratio of the % of value added in manufacturing in Algeria in 1973 to that in 1976?
Provide a succinct answer. 1.24. What is the ratio of the % of value added in manufacturing of Jamaica in 1973 to that in 1976?
Your answer should be very brief. 0.9. What is the ratio of the % of value added in manufacturing of Kenya in 1973 to that in 1976?
Your answer should be compact. 0.73. What is the ratio of the % of value added in manufacturing in Poland in 1973 to that in 1976?
Offer a terse response. 0.99. What is the ratio of the % of value added in manufacturing in Algeria in 1974 to that in 1975?
Provide a short and direct response. 0.98. What is the ratio of the % of value added in manufacturing in Jamaica in 1974 to that in 1975?
Make the answer very short. 0.99. What is the ratio of the % of value added in manufacturing of Kenya in 1974 to that in 1975?
Keep it short and to the point. 0.98. What is the ratio of the % of value added in manufacturing in Poland in 1974 to that in 1975?
Your answer should be compact. 0.98. What is the ratio of the % of value added in manufacturing of Algeria in 1974 to that in 1976?
Make the answer very short. 1.03. What is the ratio of the % of value added in manufacturing of Jamaica in 1974 to that in 1976?
Make the answer very short. 1. What is the ratio of the % of value added in manufacturing of Kenya in 1974 to that in 1976?
Provide a short and direct response. 0.78. What is the ratio of the % of value added in manufacturing of Poland in 1974 to that in 1976?
Make the answer very short. 0.99. What is the ratio of the % of value added in manufacturing of Algeria in 1975 to that in 1976?
Make the answer very short. 1.05. What is the ratio of the % of value added in manufacturing of Jamaica in 1975 to that in 1976?
Offer a terse response. 1.01. What is the ratio of the % of value added in manufacturing of Kenya in 1975 to that in 1976?
Make the answer very short. 0.8. What is the ratio of the % of value added in manufacturing in Poland in 1975 to that in 1976?
Your response must be concise. 1.01. What is the difference between the highest and the second highest % of value added in manufacturing in Algeria?
Your answer should be compact. 0.51. What is the difference between the highest and the second highest % of value added in manufacturing in Jamaica?
Provide a short and direct response. 0.57. What is the difference between the highest and the second highest % of value added in manufacturing of Kenya?
Provide a short and direct response. 8.52. What is the difference between the highest and the second highest % of value added in manufacturing in Poland?
Offer a terse response. 3.21. What is the difference between the highest and the lowest % of value added in manufacturing of Algeria?
Your response must be concise. 8.2. What is the difference between the highest and the lowest % of value added in manufacturing of Jamaica?
Provide a succinct answer. 5.44. What is the difference between the highest and the lowest % of value added in manufacturing in Kenya?
Provide a short and direct response. 11.27. What is the difference between the highest and the lowest % of value added in manufacturing in Poland?
Make the answer very short. 3.59. 